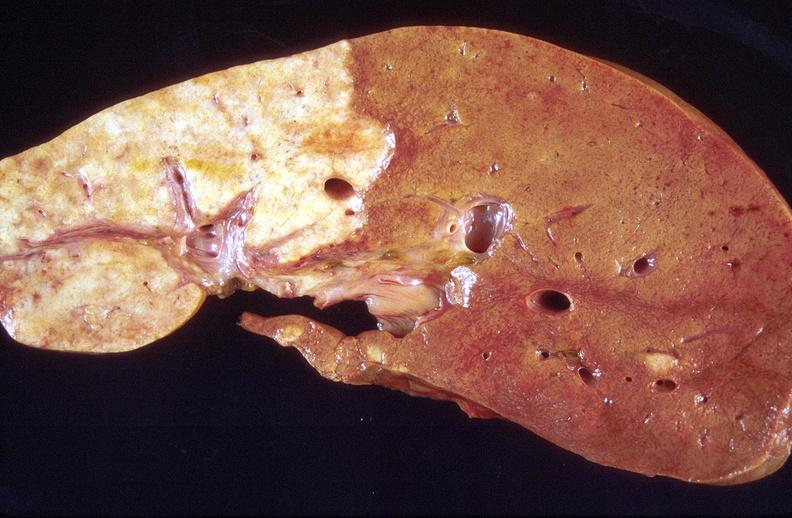s hepatobiliary present?
Answer the question using a single word or phrase. Yes 